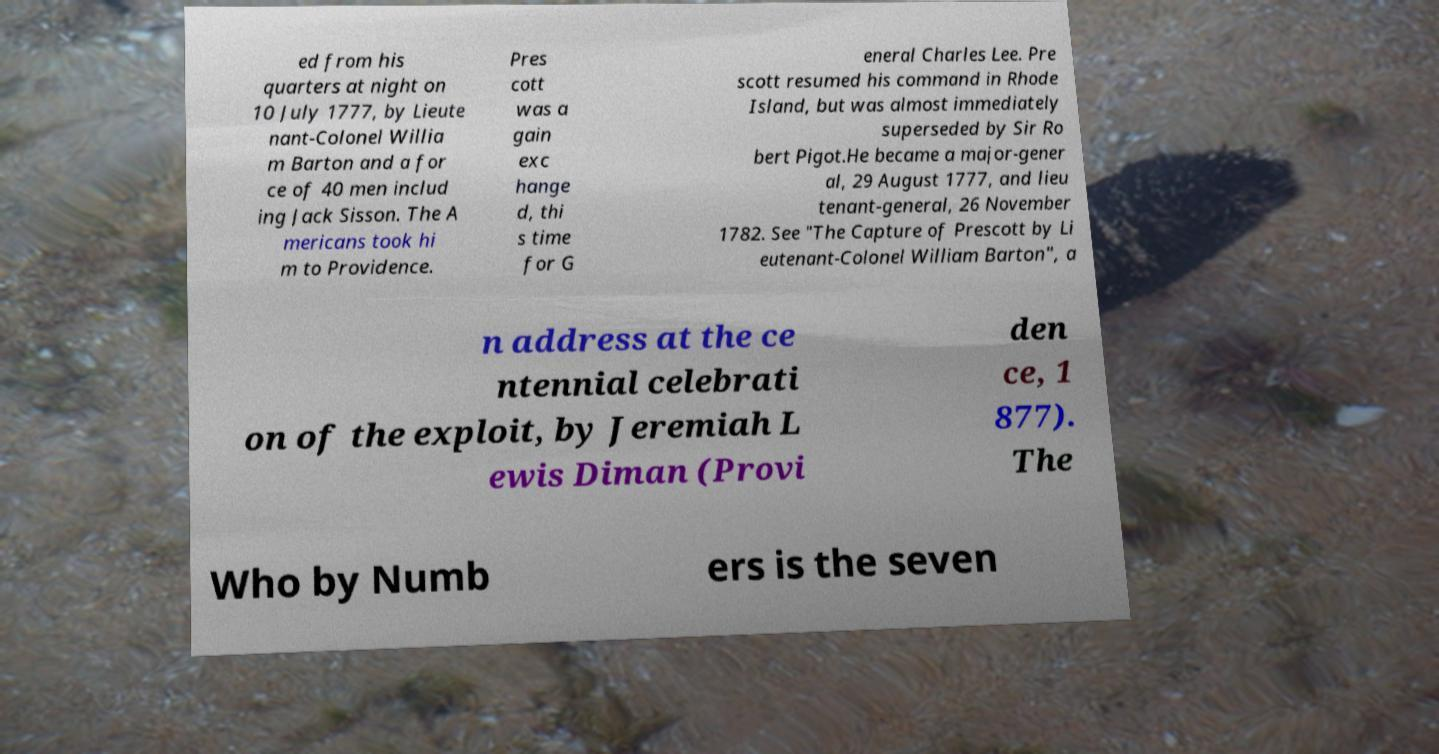Could you extract and type out the text from this image? ed from his quarters at night on 10 July 1777, by Lieute nant-Colonel Willia m Barton and a for ce of 40 men includ ing Jack Sisson. The A mericans took hi m to Providence. Pres cott was a gain exc hange d, thi s time for G eneral Charles Lee. Pre scott resumed his command in Rhode Island, but was almost immediately superseded by Sir Ro bert Pigot.He became a major-gener al, 29 August 1777, and lieu tenant-general, 26 November 1782. See "The Capture of Prescott by Li eutenant-Colonel William Barton", a n address at the ce ntennial celebrati on of the exploit, by Jeremiah L ewis Diman (Provi den ce, 1 877). The Who by Numb ers is the seven 